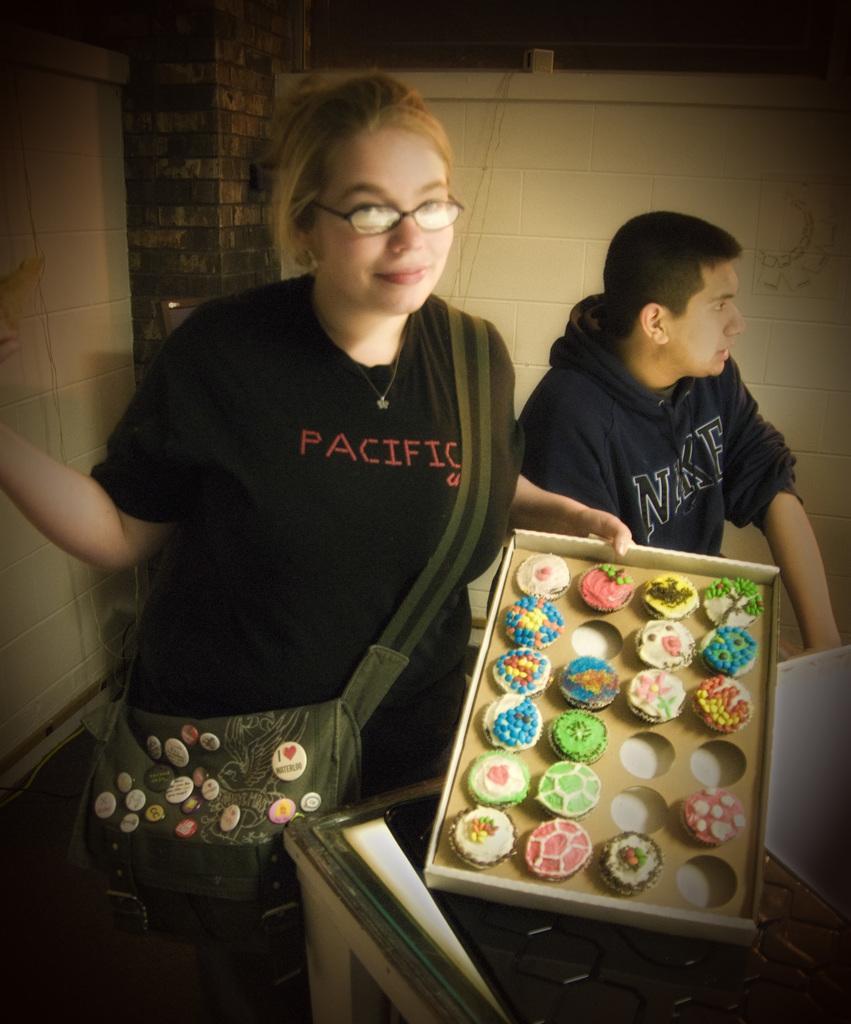How would you summarize this image in a sentence or two? In this image we can see few people. A person is holding an object. There are few cakes in the image. We can see the wall in the image. There is a bag in the image. 